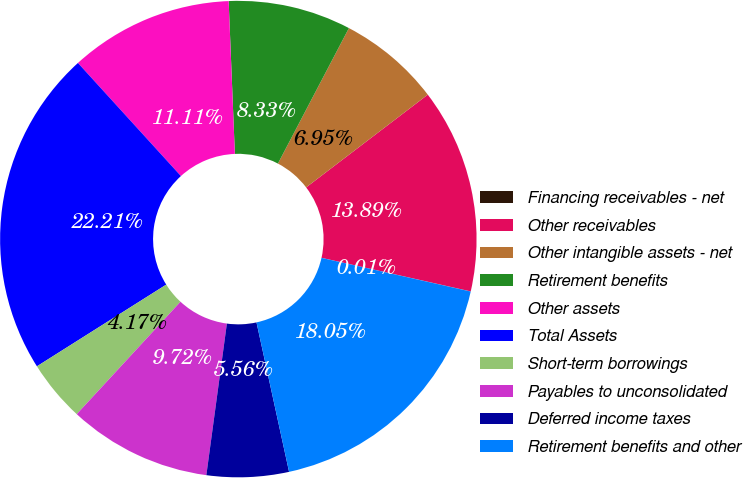<chart> <loc_0><loc_0><loc_500><loc_500><pie_chart><fcel>Financing receivables - net<fcel>Other receivables<fcel>Other intangible assets - net<fcel>Retirement benefits<fcel>Other assets<fcel>Total Assets<fcel>Short-term borrowings<fcel>Payables to unconsolidated<fcel>Deferred income taxes<fcel>Retirement benefits and other<nl><fcel>0.01%<fcel>13.89%<fcel>6.95%<fcel>8.33%<fcel>11.11%<fcel>22.21%<fcel>4.17%<fcel>9.72%<fcel>5.56%<fcel>18.05%<nl></chart> 